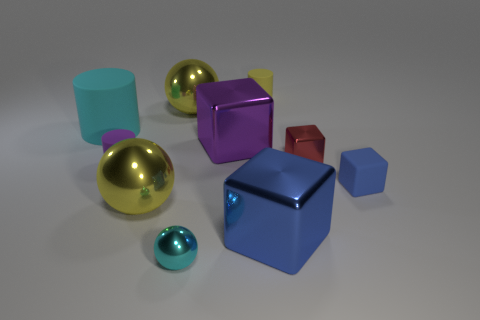There is a yellow sphere left of the yellow metal ball behind the purple shiny object; are there any purple things to the left of it?
Make the answer very short. Yes. How many other things are there of the same shape as the large purple metallic object?
Give a very brief answer. 3. What color is the rubber thing that is to the right of the small matte cylinder that is on the right side of the cyan sphere that is in front of the big blue metallic block?
Your response must be concise. Blue. How many big yellow things are there?
Keep it short and to the point. 2. What number of tiny things are purple rubber objects or red objects?
Ensure brevity in your answer.  2. What is the shape of the blue metal thing that is the same size as the cyan cylinder?
Offer a terse response. Cube. The yellow thing in front of the tiny rubber object that is on the left side of the large purple cube is made of what material?
Give a very brief answer. Metal. Do the purple matte cylinder and the blue metal cube have the same size?
Make the answer very short. No. What number of things are either large yellow metal spheres behind the small blue rubber object or small matte cylinders?
Offer a terse response. 3. There is a tiny metal thing behind the big yellow object that is in front of the tiny blue thing; what is its shape?
Keep it short and to the point. Cube. 